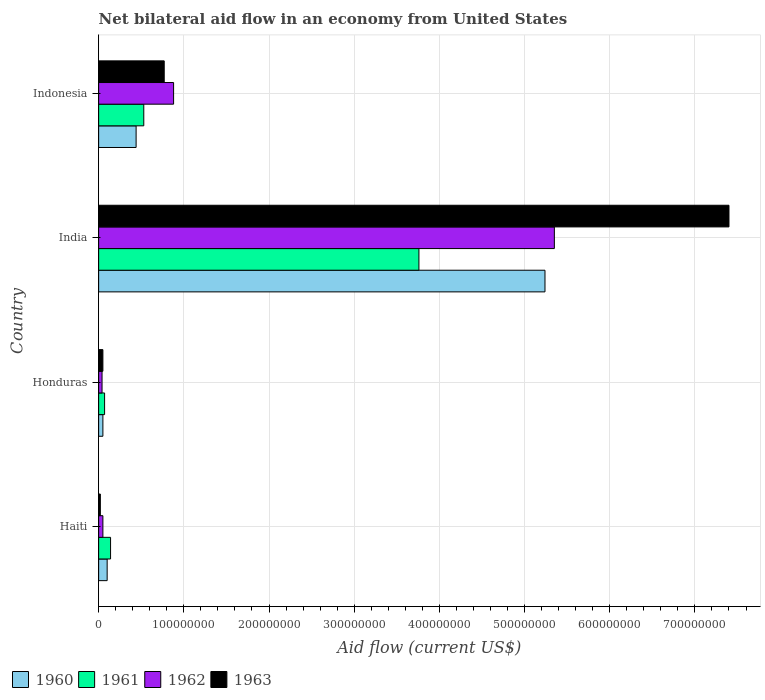How many different coloured bars are there?
Ensure brevity in your answer.  4. Are the number of bars per tick equal to the number of legend labels?
Keep it short and to the point. Yes. How many bars are there on the 2nd tick from the top?
Your response must be concise. 4. What is the label of the 4th group of bars from the top?
Ensure brevity in your answer.  Haiti. What is the net bilateral aid flow in 1963 in Indonesia?
Provide a succinct answer. 7.70e+07. Across all countries, what is the maximum net bilateral aid flow in 1963?
Ensure brevity in your answer.  7.40e+08. In which country was the net bilateral aid flow in 1960 minimum?
Provide a succinct answer. Honduras. What is the total net bilateral aid flow in 1961 in the graph?
Give a very brief answer. 4.50e+08. What is the difference between the net bilateral aid flow in 1960 in Honduras and that in Indonesia?
Your answer should be very brief. -3.90e+07. What is the difference between the net bilateral aid flow in 1963 in India and the net bilateral aid flow in 1962 in Haiti?
Provide a succinct answer. 7.35e+08. What is the average net bilateral aid flow in 1960 per country?
Your answer should be very brief. 1.46e+08. What is the difference between the net bilateral aid flow in 1963 and net bilateral aid flow in 1960 in Indonesia?
Your response must be concise. 3.30e+07. In how many countries, is the net bilateral aid flow in 1962 greater than 400000000 US$?
Offer a very short reply. 1. What is the ratio of the net bilateral aid flow in 1963 in Haiti to that in Indonesia?
Make the answer very short. 0.03. Is the difference between the net bilateral aid flow in 1963 in Haiti and India greater than the difference between the net bilateral aid flow in 1960 in Haiti and India?
Your response must be concise. No. What is the difference between the highest and the second highest net bilateral aid flow in 1963?
Provide a succinct answer. 6.63e+08. What is the difference between the highest and the lowest net bilateral aid flow in 1960?
Offer a terse response. 5.19e+08. In how many countries, is the net bilateral aid flow in 1963 greater than the average net bilateral aid flow in 1963 taken over all countries?
Provide a short and direct response. 1. What does the 4th bar from the top in Indonesia represents?
Ensure brevity in your answer.  1960. How many bars are there?
Your response must be concise. 16. How many countries are there in the graph?
Ensure brevity in your answer.  4. Does the graph contain any zero values?
Keep it short and to the point. No. How many legend labels are there?
Provide a succinct answer. 4. What is the title of the graph?
Your answer should be very brief. Net bilateral aid flow in an economy from United States. What is the label or title of the Y-axis?
Keep it short and to the point. Country. What is the Aid flow (current US$) of 1961 in Haiti?
Offer a terse response. 1.40e+07. What is the Aid flow (current US$) of 1962 in Haiti?
Offer a very short reply. 5.00e+06. What is the Aid flow (current US$) of 1963 in Haiti?
Offer a very short reply. 2.00e+06. What is the Aid flow (current US$) of 1962 in Honduras?
Offer a terse response. 4.00e+06. What is the Aid flow (current US$) of 1960 in India?
Your response must be concise. 5.24e+08. What is the Aid flow (current US$) in 1961 in India?
Ensure brevity in your answer.  3.76e+08. What is the Aid flow (current US$) in 1962 in India?
Make the answer very short. 5.35e+08. What is the Aid flow (current US$) in 1963 in India?
Offer a very short reply. 7.40e+08. What is the Aid flow (current US$) of 1960 in Indonesia?
Provide a short and direct response. 4.40e+07. What is the Aid flow (current US$) of 1961 in Indonesia?
Provide a short and direct response. 5.30e+07. What is the Aid flow (current US$) of 1962 in Indonesia?
Your answer should be very brief. 8.80e+07. What is the Aid flow (current US$) of 1963 in Indonesia?
Offer a terse response. 7.70e+07. Across all countries, what is the maximum Aid flow (current US$) in 1960?
Provide a short and direct response. 5.24e+08. Across all countries, what is the maximum Aid flow (current US$) in 1961?
Keep it short and to the point. 3.76e+08. Across all countries, what is the maximum Aid flow (current US$) of 1962?
Your answer should be very brief. 5.35e+08. Across all countries, what is the maximum Aid flow (current US$) of 1963?
Make the answer very short. 7.40e+08. Across all countries, what is the minimum Aid flow (current US$) in 1963?
Ensure brevity in your answer.  2.00e+06. What is the total Aid flow (current US$) in 1960 in the graph?
Give a very brief answer. 5.83e+08. What is the total Aid flow (current US$) in 1961 in the graph?
Offer a terse response. 4.50e+08. What is the total Aid flow (current US$) in 1962 in the graph?
Your answer should be compact. 6.32e+08. What is the total Aid flow (current US$) of 1963 in the graph?
Ensure brevity in your answer.  8.24e+08. What is the difference between the Aid flow (current US$) in 1961 in Haiti and that in Honduras?
Offer a terse response. 7.00e+06. What is the difference between the Aid flow (current US$) in 1963 in Haiti and that in Honduras?
Give a very brief answer. -3.00e+06. What is the difference between the Aid flow (current US$) of 1960 in Haiti and that in India?
Provide a succinct answer. -5.14e+08. What is the difference between the Aid flow (current US$) in 1961 in Haiti and that in India?
Ensure brevity in your answer.  -3.62e+08. What is the difference between the Aid flow (current US$) in 1962 in Haiti and that in India?
Ensure brevity in your answer.  -5.30e+08. What is the difference between the Aid flow (current US$) in 1963 in Haiti and that in India?
Offer a very short reply. -7.38e+08. What is the difference between the Aid flow (current US$) of 1960 in Haiti and that in Indonesia?
Ensure brevity in your answer.  -3.40e+07. What is the difference between the Aid flow (current US$) in 1961 in Haiti and that in Indonesia?
Offer a very short reply. -3.90e+07. What is the difference between the Aid flow (current US$) in 1962 in Haiti and that in Indonesia?
Your answer should be compact. -8.30e+07. What is the difference between the Aid flow (current US$) in 1963 in Haiti and that in Indonesia?
Your answer should be compact. -7.50e+07. What is the difference between the Aid flow (current US$) in 1960 in Honduras and that in India?
Your answer should be very brief. -5.19e+08. What is the difference between the Aid flow (current US$) of 1961 in Honduras and that in India?
Keep it short and to the point. -3.69e+08. What is the difference between the Aid flow (current US$) of 1962 in Honduras and that in India?
Offer a terse response. -5.31e+08. What is the difference between the Aid flow (current US$) in 1963 in Honduras and that in India?
Give a very brief answer. -7.35e+08. What is the difference between the Aid flow (current US$) in 1960 in Honduras and that in Indonesia?
Give a very brief answer. -3.90e+07. What is the difference between the Aid flow (current US$) of 1961 in Honduras and that in Indonesia?
Keep it short and to the point. -4.60e+07. What is the difference between the Aid flow (current US$) in 1962 in Honduras and that in Indonesia?
Provide a short and direct response. -8.40e+07. What is the difference between the Aid flow (current US$) of 1963 in Honduras and that in Indonesia?
Offer a very short reply. -7.20e+07. What is the difference between the Aid flow (current US$) of 1960 in India and that in Indonesia?
Offer a very short reply. 4.80e+08. What is the difference between the Aid flow (current US$) in 1961 in India and that in Indonesia?
Your response must be concise. 3.23e+08. What is the difference between the Aid flow (current US$) in 1962 in India and that in Indonesia?
Your answer should be very brief. 4.47e+08. What is the difference between the Aid flow (current US$) of 1963 in India and that in Indonesia?
Ensure brevity in your answer.  6.63e+08. What is the difference between the Aid flow (current US$) of 1960 in Haiti and the Aid flow (current US$) of 1963 in Honduras?
Ensure brevity in your answer.  5.00e+06. What is the difference between the Aid flow (current US$) of 1961 in Haiti and the Aid flow (current US$) of 1963 in Honduras?
Offer a terse response. 9.00e+06. What is the difference between the Aid flow (current US$) in 1960 in Haiti and the Aid flow (current US$) in 1961 in India?
Provide a succinct answer. -3.66e+08. What is the difference between the Aid flow (current US$) of 1960 in Haiti and the Aid flow (current US$) of 1962 in India?
Your response must be concise. -5.25e+08. What is the difference between the Aid flow (current US$) in 1960 in Haiti and the Aid flow (current US$) in 1963 in India?
Make the answer very short. -7.30e+08. What is the difference between the Aid flow (current US$) of 1961 in Haiti and the Aid flow (current US$) of 1962 in India?
Provide a short and direct response. -5.21e+08. What is the difference between the Aid flow (current US$) of 1961 in Haiti and the Aid flow (current US$) of 1963 in India?
Your response must be concise. -7.26e+08. What is the difference between the Aid flow (current US$) of 1962 in Haiti and the Aid flow (current US$) of 1963 in India?
Make the answer very short. -7.35e+08. What is the difference between the Aid flow (current US$) in 1960 in Haiti and the Aid flow (current US$) in 1961 in Indonesia?
Your response must be concise. -4.30e+07. What is the difference between the Aid flow (current US$) in 1960 in Haiti and the Aid flow (current US$) in 1962 in Indonesia?
Your answer should be compact. -7.80e+07. What is the difference between the Aid flow (current US$) in 1960 in Haiti and the Aid flow (current US$) in 1963 in Indonesia?
Ensure brevity in your answer.  -6.70e+07. What is the difference between the Aid flow (current US$) of 1961 in Haiti and the Aid flow (current US$) of 1962 in Indonesia?
Your answer should be very brief. -7.40e+07. What is the difference between the Aid flow (current US$) of 1961 in Haiti and the Aid flow (current US$) of 1963 in Indonesia?
Your answer should be very brief. -6.30e+07. What is the difference between the Aid flow (current US$) of 1962 in Haiti and the Aid flow (current US$) of 1963 in Indonesia?
Provide a short and direct response. -7.20e+07. What is the difference between the Aid flow (current US$) of 1960 in Honduras and the Aid flow (current US$) of 1961 in India?
Your response must be concise. -3.71e+08. What is the difference between the Aid flow (current US$) in 1960 in Honduras and the Aid flow (current US$) in 1962 in India?
Offer a terse response. -5.30e+08. What is the difference between the Aid flow (current US$) of 1960 in Honduras and the Aid flow (current US$) of 1963 in India?
Offer a very short reply. -7.35e+08. What is the difference between the Aid flow (current US$) in 1961 in Honduras and the Aid flow (current US$) in 1962 in India?
Make the answer very short. -5.28e+08. What is the difference between the Aid flow (current US$) in 1961 in Honduras and the Aid flow (current US$) in 1963 in India?
Ensure brevity in your answer.  -7.33e+08. What is the difference between the Aid flow (current US$) of 1962 in Honduras and the Aid flow (current US$) of 1963 in India?
Your answer should be compact. -7.36e+08. What is the difference between the Aid flow (current US$) in 1960 in Honduras and the Aid flow (current US$) in 1961 in Indonesia?
Your response must be concise. -4.80e+07. What is the difference between the Aid flow (current US$) of 1960 in Honduras and the Aid flow (current US$) of 1962 in Indonesia?
Your answer should be very brief. -8.30e+07. What is the difference between the Aid flow (current US$) in 1960 in Honduras and the Aid flow (current US$) in 1963 in Indonesia?
Offer a very short reply. -7.20e+07. What is the difference between the Aid flow (current US$) of 1961 in Honduras and the Aid flow (current US$) of 1962 in Indonesia?
Ensure brevity in your answer.  -8.10e+07. What is the difference between the Aid flow (current US$) in 1961 in Honduras and the Aid flow (current US$) in 1963 in Indonesia?
Make the answer very short. -7.00e+07. What is the difference between the Aid flow (current US$) of 1962 in Honduras and the Aid flow (current US$) of 1963 in Indonesia?
Give a very brief answer. -7.30e+07. What is the difference between the Aid flow (current US$) of 1960 in India and the Aid flow (current US$) of 1961 in Indonesia?
Your answer should be compact. 4.71e+08. What is the difference between the Aid flow (current US$) in 1960 in India and the Aid flow (current US$) in 1962 in Indonesia?
Offer a very short reply. 4.36e+08. What is the difference between the Aid flow (current US$) in 1960 in India and the Aid flow (current US$) in 1963 in Indonesia?
Provide a succinct answer. 4.47e+08. What is the difference between the Aid flow (current US$) of 1961 in India and the Aid flow (current US$) of 1962 in Indonesia?
Ensure brevity in your answer.  2.88e+08. What is the difference between the Aid flow (current US$) of 1961 in India and the Aid flow (current US$) of 1963 in Indonesia?
Offer a very short reply. 2.99e+08. What is the difference between the Aid flow (current US$) of 1962 in India and the Aid flow (current US$) of 1963 in Indonesia?
Offer a very short reply. 4.58e+08. What is the average Aid flow (current US$) in 1960 per country?
Offer a terse response. 1.46e+08. What is the average Aid flow (current US$) of 1961 per country?
Provide a succinct answer. 1.12e+08. What is the average Aid flow (current US$) in 1962 per country?
Provide a short and direct response. 1.58e+08. What is the average Aid flow (current US$) in 1963 per country?
Your answer should be compact. 2.06e+08. What is the difference between the Aid flow (current US$) of 1961 and Aid flow (current US$) of 1962 in Haiti?
Keep it short and to the point. 9.00e+06. What is the difference between the Aid flow (current US$) of 1962 and Aid flow (current US$) of 1963 in Haiti?
Your answer should be compact. 3.00e+06. What is the difference between the Aid flow (current US$) in 1961 and Aid flow (current US$) in 1963 in Honduras?
Offer a very short reply. 2.00e+06. What is the difference between the Aid flow (current US$) of 1960 and Aid flow (current US$) of 1961 in India?
Your response must be concise. 1.48e+08. What is the difference between the Aid flow (current US$) in 1960 and Aid flow (current US$) in 1962 in India?
Keep it short and to the point. -1.10e+07. What is the difference between the Aid flow (current US$) of 1960 and Aid flow (current US$) of 1963 in India?
Your response must be concise. -2.16e+08. What is the difference between the Aid flow (current US$) of 1961 and Aid flow (current US$) of 1962 in India?
Keep it short and to the point. -1.59e+08. What is the difference between the Aid flow (current US$) in 1961 and Aid flow (current US$) in 1963 in India?
Provide a succinct answer. -3.64e+08. What is the difference between the Aid flow (current US$) in 1962 and Aid flow (current US$) in 1963 in India?
Make the answer very short. -2.05e+08. What is the difference between the Aid flow (current US$) of 1960 and Aid flow (current US$) of 1961 in Indonesia?
Ensure brevity in your answer.  -9.00e+06. What is the difference between the Aid flow (current US$) in 1960 and Aid flow (current US$) in 1962 in Indonesia?
Offer a very short reply. -4.40e+07. What is the difference between the Aid flow (current US$) of 1960 and Aid flow (current US$) of 1963 in Indonesia?
Your answer should be compact. -3.30e+07. What is the difference between the Aid flow (current US$) of 1961 and Aid flow (current US$) of 1962 in Indonesia?
Your response must be concise. -3.50e+07. What is the difference between the Aid flow (current US$) in 1961 and Aid flow (current US$) in 1963 in Indonesia?
Your response must be concise. -2.40e+07. What is the difference between the Aid flow (current US$) in 1962 and Aid flow (current US$) in 1963 in Indonesia?
Offer a terse response. 1.10e+07. What is the ratio of the Aid flow (current US$) of 1960 in Haiti to that in Honduras?
Provide a succinct answer. 2. What is the ratio of the Aid flow (current US$) of 1961 in Haiti to that in Honduras?
Your response must be concise. 2. What is the ratio of the Aid flow (current US$) of 1960 in Haiti to that in India?
Your answer should be very brief. 0.02. What is the ratio of the Aid flow (current US$) in 1961 in Haiti to that in India?
Provide a succinct answer. 0.04. What is the ratio of the Aid flow (current US$) in 1962 in Haiti to that in India?
Provide a succinct answer. 0.01. What is the ratio of the Aid flow (current US$) of 1963 in Haiti to that in India?
Your response must be concise. 0. What is the ratio of the Aid flow (current US$) in 1960 in Haiti to that in Indonesia?
Provide a succinct answer. 0.23. What is the ratio of the Aid flow (current US$) of 1961 in Haiti to that in Indonesia?
Your response must be concise. 0.26. What is the ratio of the Aid flow (current US$) of 1962 in Haiti to that in Indonesia?
Provide a succinct answer. 0.06. What is the ratio of the Aid flow (current US$) of 1963 in Haiti to that in Indonesia?
Your answer should be compact. 0.03. What is the ratio of the Aid flow (current US$) in 1960 in Honduras to that in India?
Give a very brief answer. 0.01. What is the ratio of the Aid flow (current US$) in 1961 in Honduras to that in India?
Your answer should be compact. 0.02. What is the ratio of the Aid flow (current US$) of 1962 in Honduras to that in India?
Make the answer very short. 0.01. What is the ratio of the Aid flow (current US$) of 1963 in Honduras to that in India?
Ensure brevity in your answer.  0.01. What is the ratio of the Aid flow (current US$) of 1960 in Honduras to that in Indonesia?
Ensure brevity in your answer.  0.11. What is the ratio of the Aid flow (current US$) of 1961 in Honduras to that in Indonesia?
Offer a very short reply. 0.13. What is the ratio of the Aid flow (current US$) of 1962 in Honduras to that in Indonesia?
Give a very brief answer. 0.05. What is the ratio of the Aid flow (current US$) in 1963 in Honduras to that in Indonesia?
Ensure brevity in your answer.  0.06. What is the ratio of the Aid flow (current US$) in 1960 in India to that in Indonesia?
Provide a short and direct response. 11.91. What is the ratio of the Aid flow (current US$) of 1961 in India to that in Indonesia?
Your answer should be compact. 7.09. What is the ratio of the Aid flow (current US$) of 1962 in India to that in Indonesia?
Make the answer very short. 6.08. What is the ratio of the Aid flow (current US$) of 1963 in India to that in Indonesia?
Your answer should be compact. 9.61. What is the difference between the highest and the second highest Aid flow (current US$) of 1960?
Your answer should be compact. 4.80e+08. What is the difference between the highest and the second highest Aid flow (current US$) in 1961?
Ensure brevity in your answer.  3.23e+08. What is the difference between the highest and the second highest Aid flow (current US$) of 1962?
Make the answer very short. 4.47e+08. What is the difference between the highest and the second highest Aid flow (current US$) in 1963?
Offer a very short reply. 6.63e+08. What is the difference between the highest and the lowest Aid flow (current US$) in 1960?
Provide a short and direct response. 5.19e+08. What is the difference between the highest and the lowest Aid flow (current US$) of 1961?
Provide a succinct answer. 3.69e+08. What is the difference between the highest and the lowest Aid flow (current US$) of 1962?
Keep it short and to the point. 5.31e+08. What is the difference between the highest and the lowest Aid flow (current US$) of 1963?
Keep it short and to the point. 7.38e+08. 